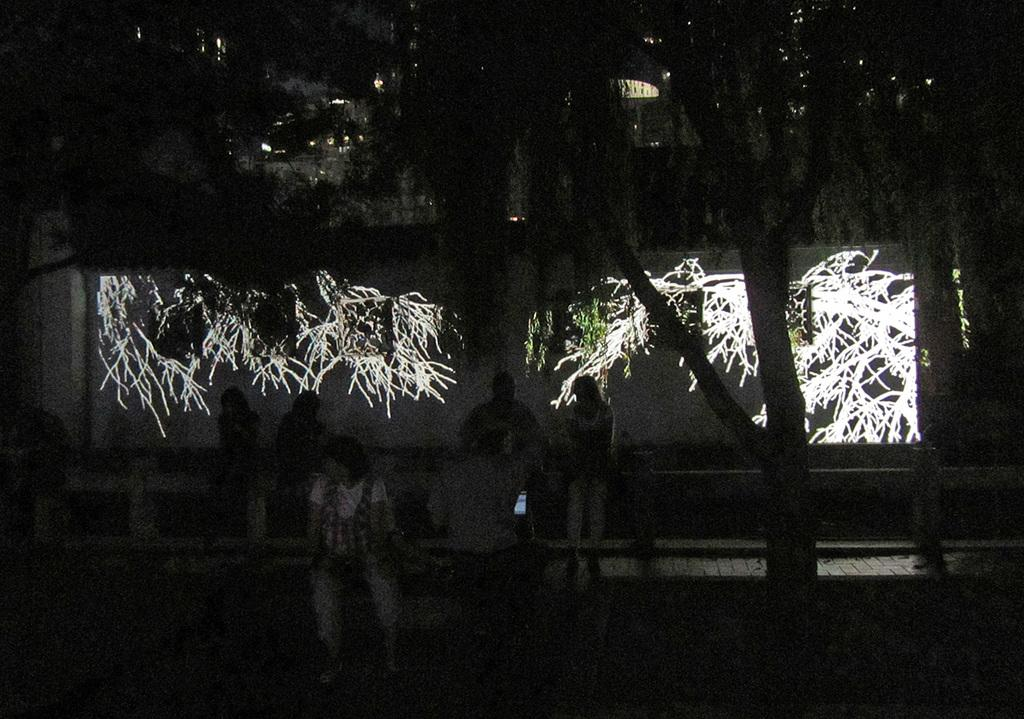What is the overall lighting condition in the image? The image is dark. What are the people in the image doing? There are people sitting in the image. What is being illuminated in the image? The lights focused on the trees are illuminating them. What can be seen in the background of the image? There is a building in the background of the image. Can you see a beetle crawling on the building in the image? There is no beetle present in the image, so it cannot be seen crawling on the building. What type of truck is parked near the people in the image? There is no truck present in the image; only the people and the building are visible. 